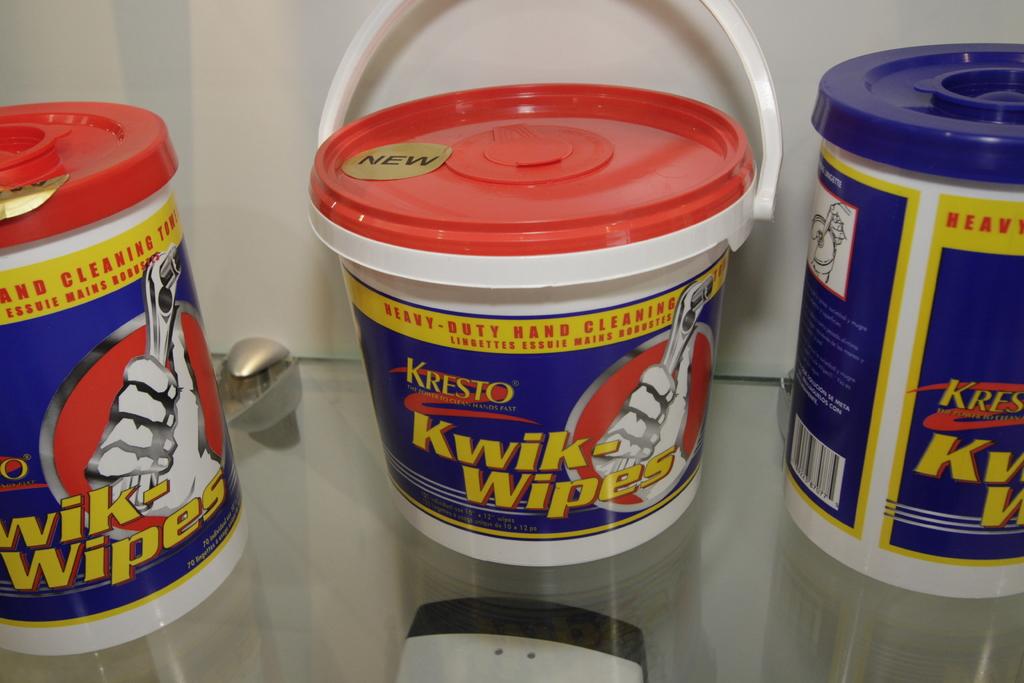What are kiwi wipes used for?
Make the answer very short. Hand cleaning. What is the name of the product?
Your response must be concise. Kwik wipes. 